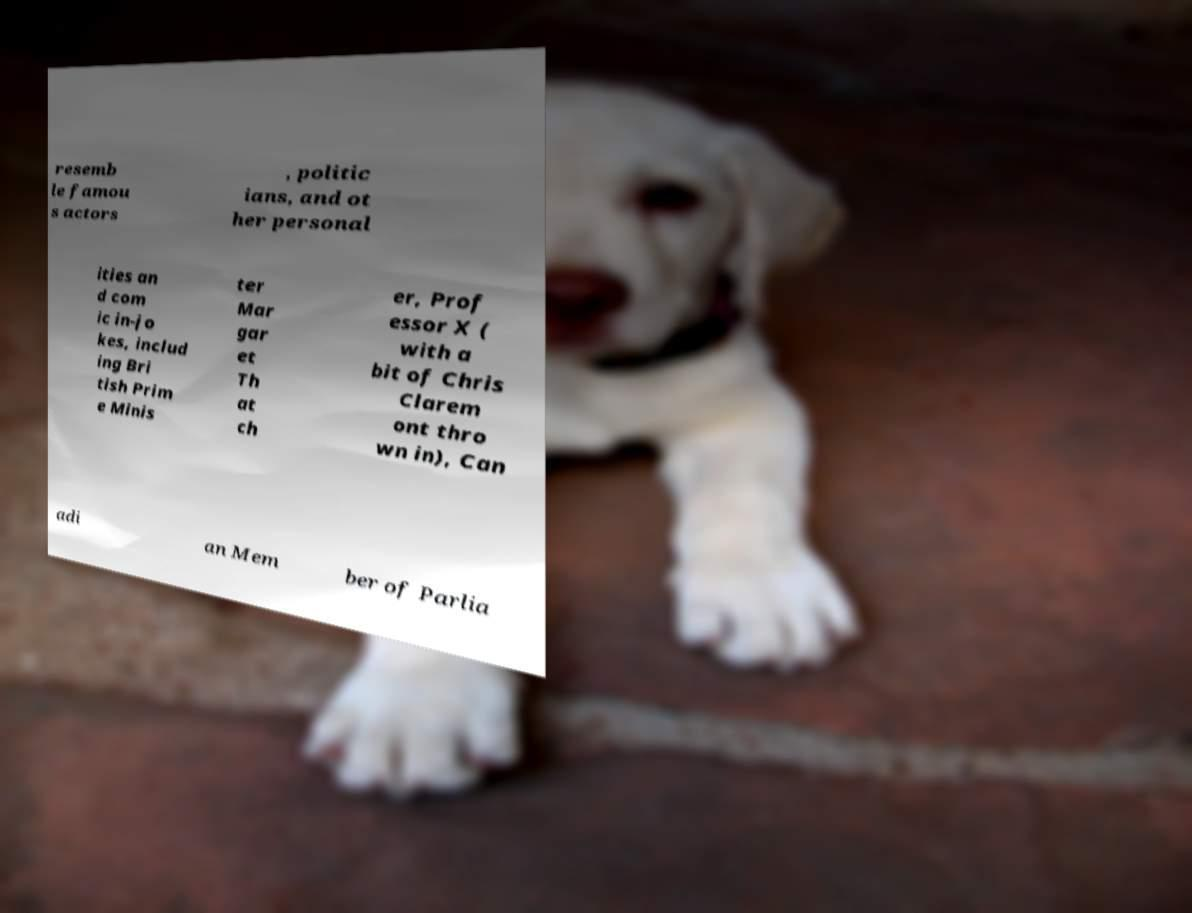For documentation purposes, I need the text within this image transcribed. Could you provide that? resemb le famou s actors , politic ians, and ot her personal ities an d com ic in-jo kes, includ ing Bri tish Prim e Minis ter Mar gar et Th at ch er, Prof essor X ( with a bit of Chris Clarem ont thro wn in), Can adi an Mem ber of Parlia 